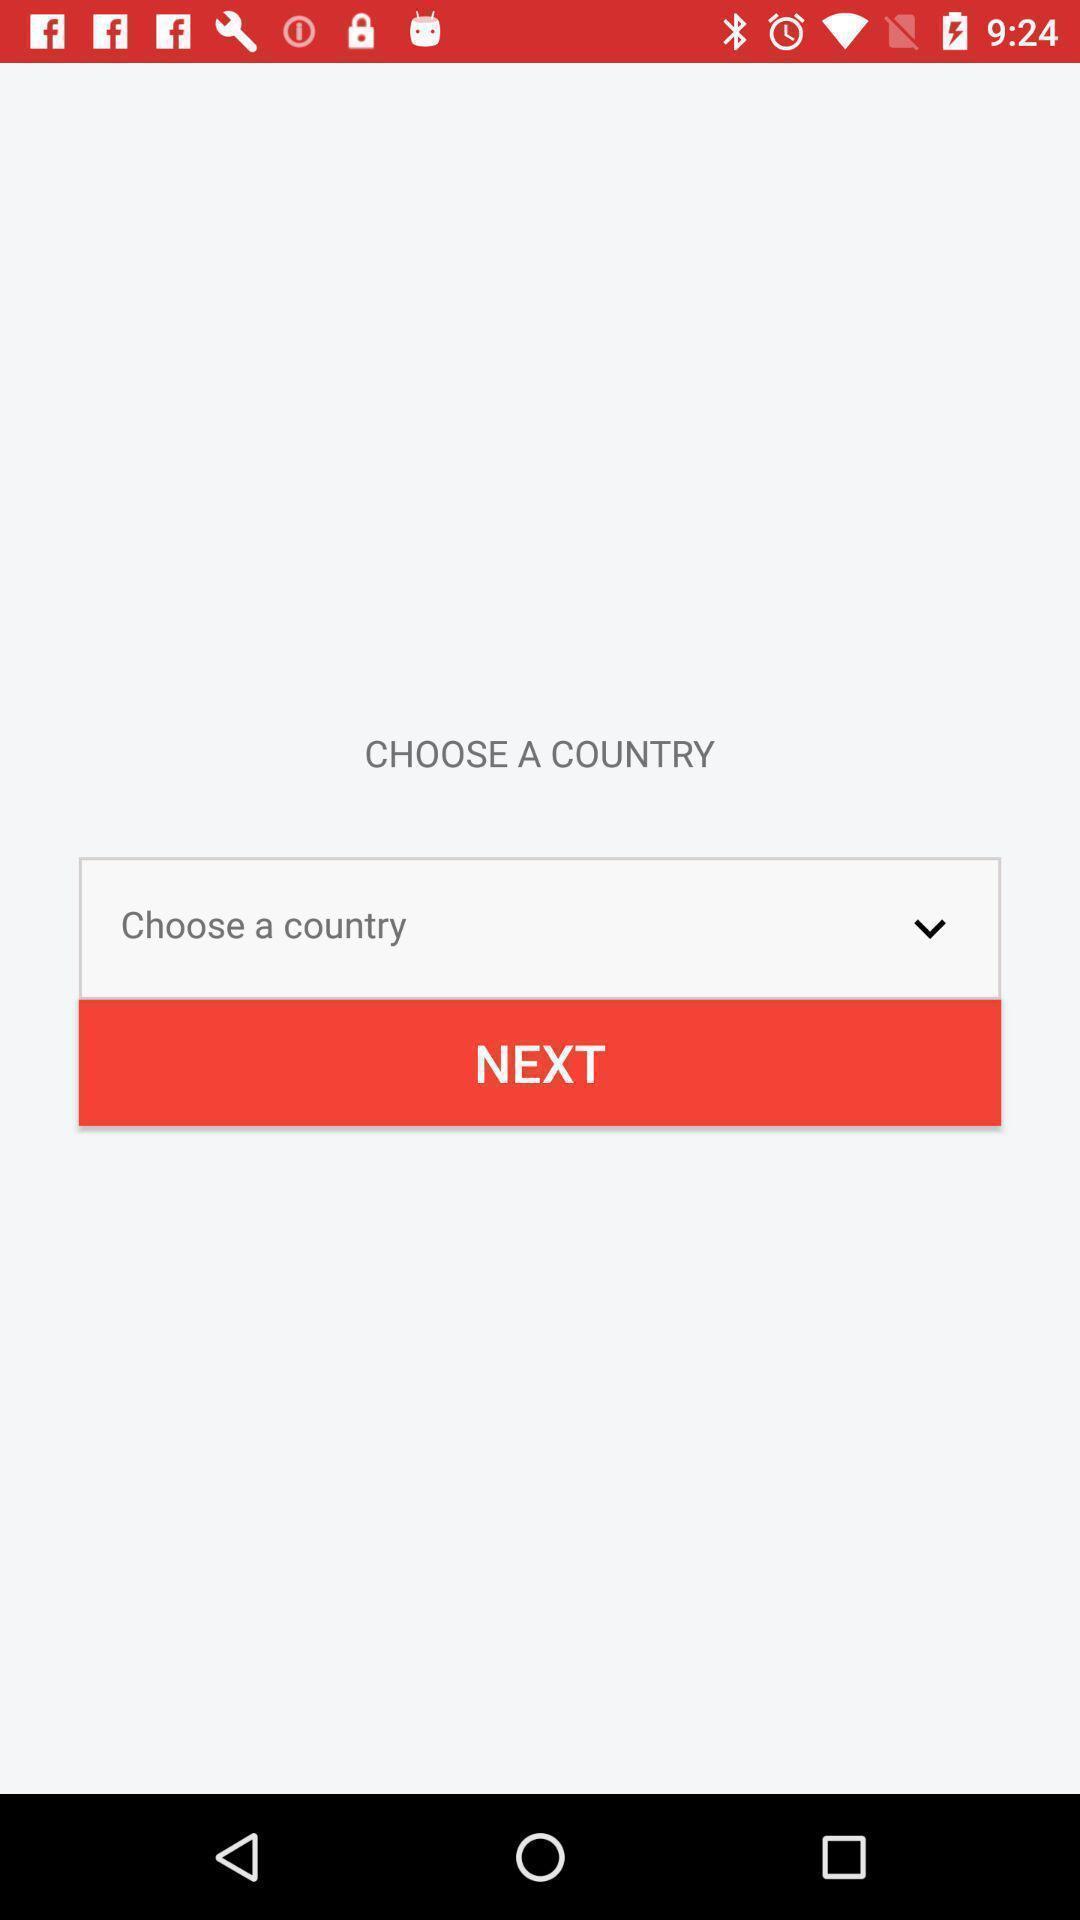Provide a description of this screenshot. Page shows to select your country. 